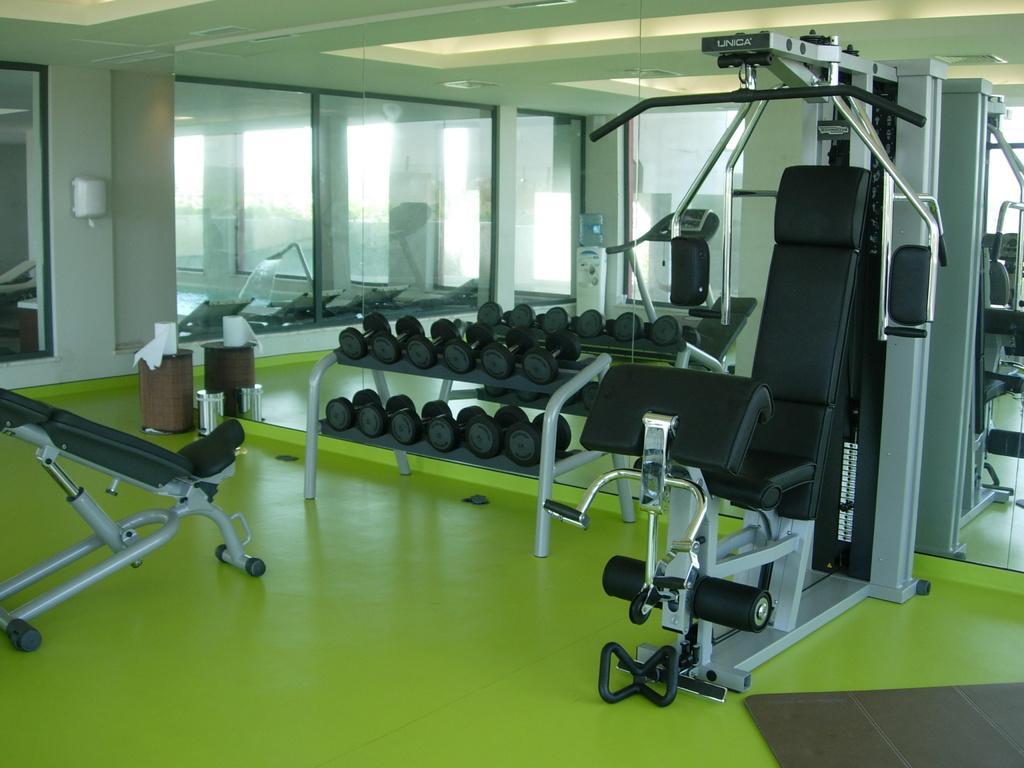Describe this image in one or two sentences. In this image I can see few gym equipment and I can see number of dumbbells. I can also see tissue rolls over here and I can see colour of floor is green. 